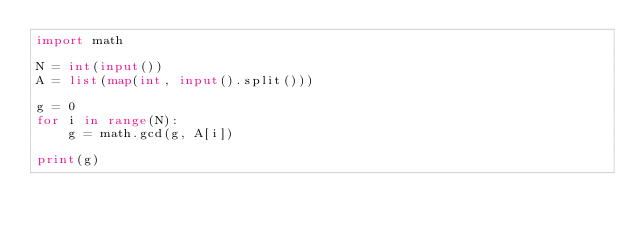<code> <loc_0><loc_0><loc_500><loc_500><_Python_>import math

N = int(input())
A = list(map(int, input().split()))

g = 0
for i in range(N):
    g = math.gcd(g, A[i])

print(g)</code> 